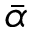Convert formula to latex. <formula><loc_0><loc_0><loc_500><loc_500>\ B a r { \alpha }</formula> 